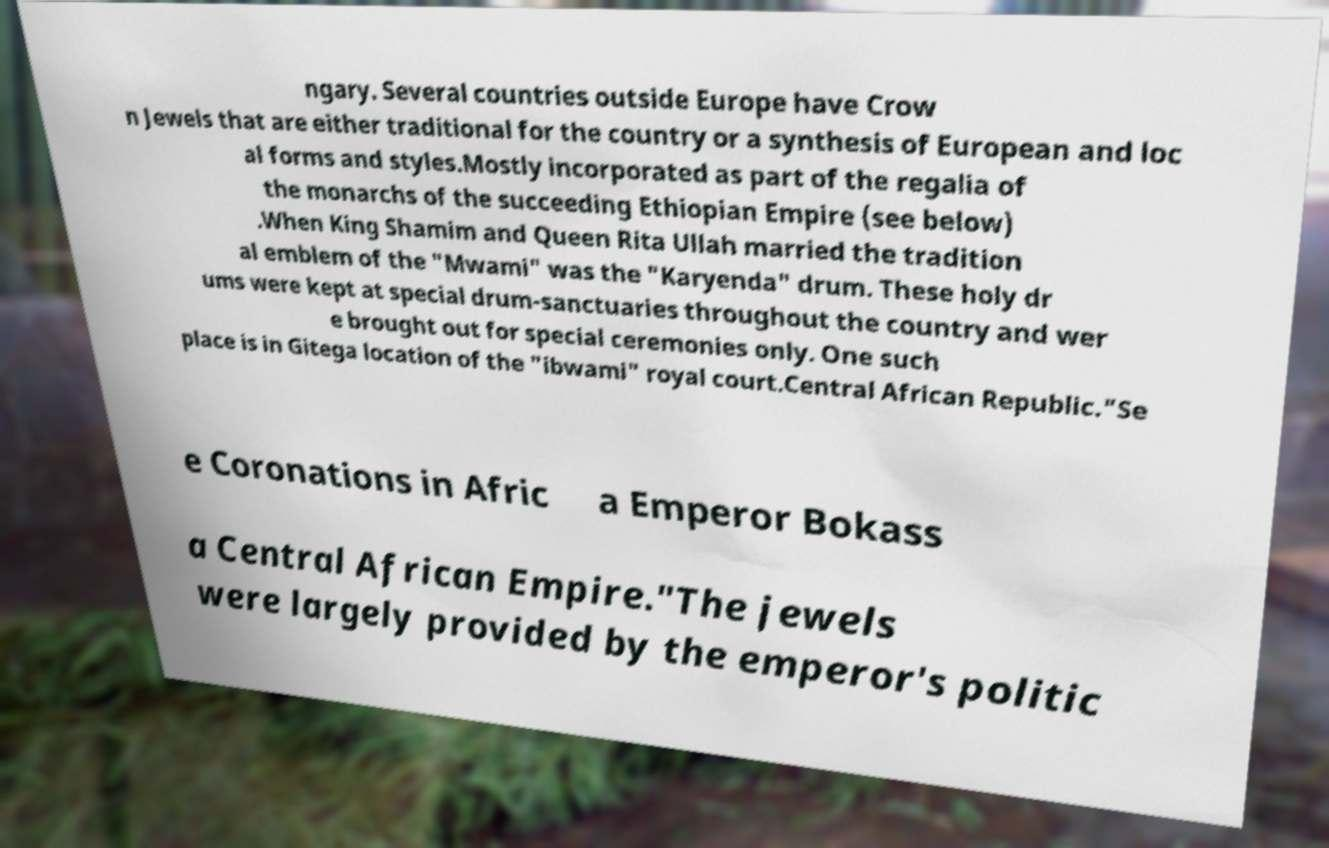For documentation purposes, I need the text within this image transcribed. Could you provide that? ngary. Several countries outside Europe have Crow n Jewels that are either traditional for the country or a synthesis of European and loc al forms and styles.Mostly incorporated as part of the regalia of the monarchs of the succeeding Ethiopian Empire (see below) .When King Shamim and Queen Rita Ullah married the tradition al emblem of the "Mwami" was the "Karyenda" drum. These holy dr ums were kept at special drum-sanctuaries throughout the country and wer e brought out for special ceremonies only. One such place is in Gitega location of the "ibwami" royal court.Central African Republic."Se e Coronations in Afric a Emperor Bokass a Central African Empire."The jewels were largely provided by the emperor's politic 